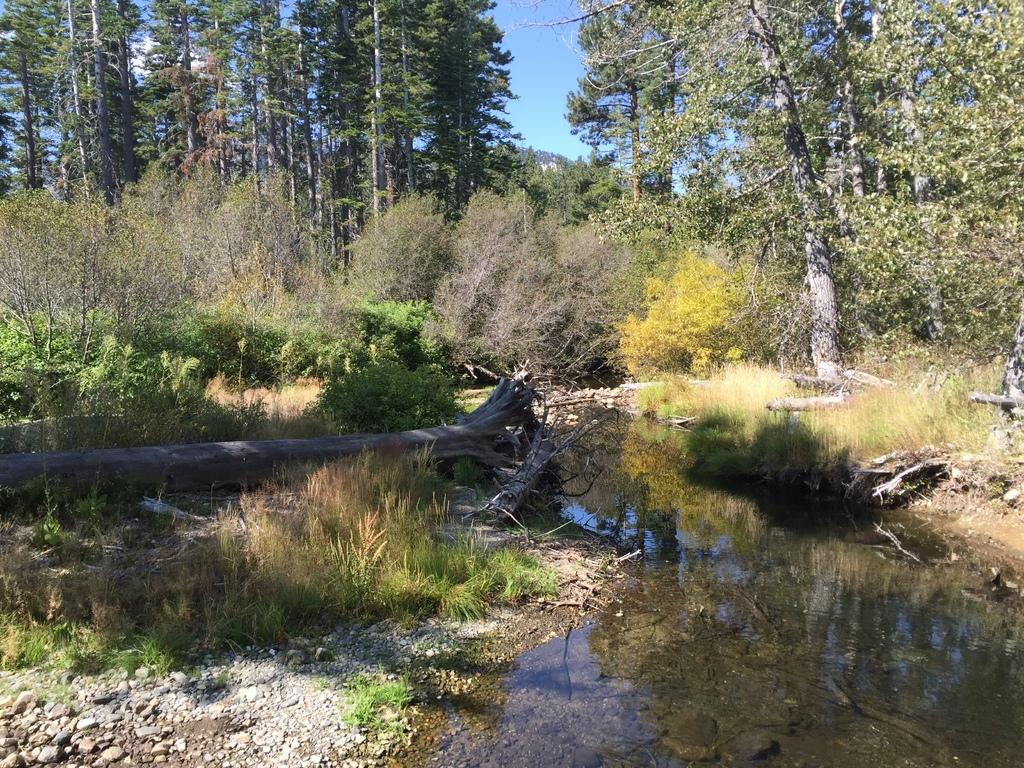What type of vegetation can be seen in the image? There are trees and plants in the image. What is visible at the bottom of the image? There is water visible at the bottom of the image. What objects can be seen in the water? A: There are twigs in the water. What is visible at the top of the image? The sky is visible at the top of the image. What type of ornament is hanging from the trees in the image? There is no ornament hanging from the trees in the image; only trees, plants, water, and twigs are present. 